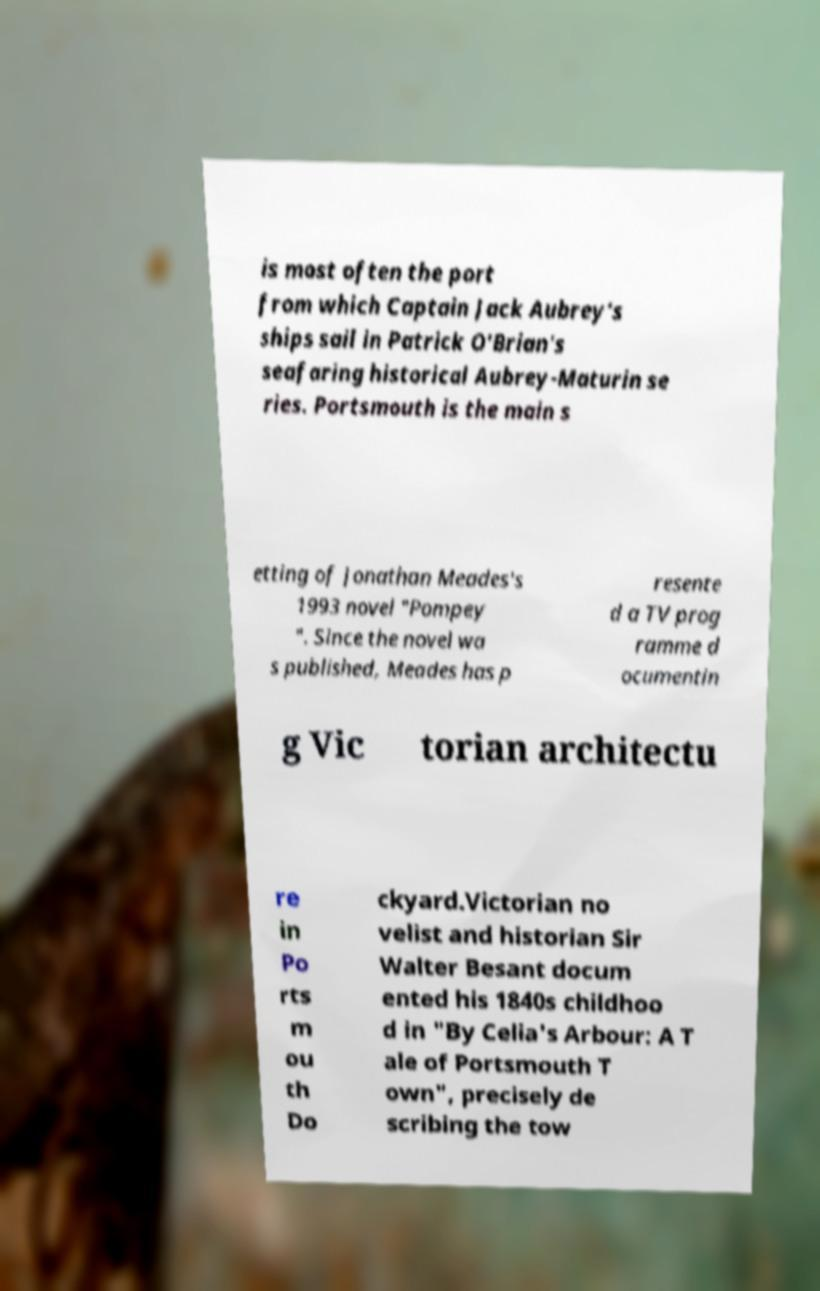Can you read and provide the text displayed in the image?This photo seems to have some interesting text. Can you extract and type it out for me? is most often the port from which Captain Jack Aubrey's ships sail in Patrick O'Brian's seafaring historical Aubrey-Maturin se ries. Portsmouth is the main s etting of Jonathan Meades's 1993 novel "Pompey ". Since the novel wa s published, Meades has p resente d a TV prog ramme d ocumentin g Vic torian architectu re in Po rts m ou th Do ckyard.Victorian no velist and historian Sir Walter Besant docum ented his 1840s childhoo d in "By Celia's Arbour: A T ale of Portsmouth T own", precisely de scribing the tow 